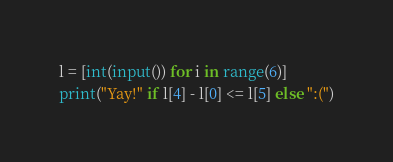<code> <loc_0><loc_0><loc_500><loc_500><_Python_>l = [int(input()) for i in range(6)]
print("Yay!" if l[4] - l[0] <= l[5] else ":(")</code> 